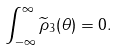<formula> <loc_0><loc_0><loc_500><loc_500>\int _ { - \infty } ^ { \infty } \widetilde { \rho } _ { 3 } ( \theta ) = 0 .</formula> 